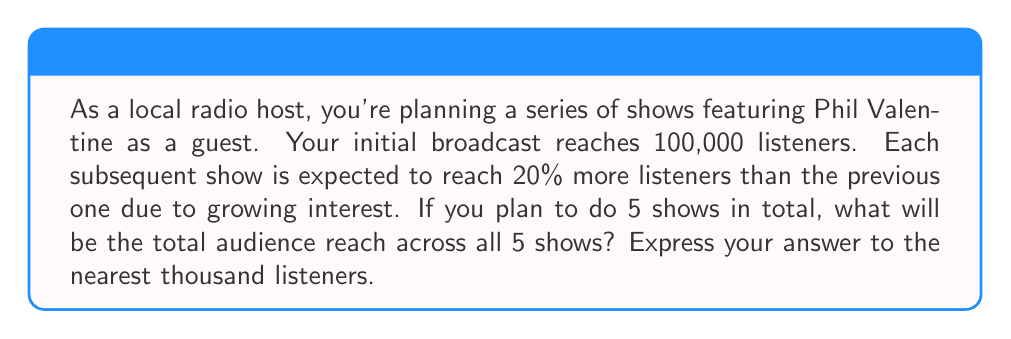Help me with this question. To solve this problem, we need to use the formula for the sum of a geometric series:

$$S_n = \frac{a(1-r^n)}{1-r}$$

Where:
$S_n$ is the sum of the series
$a$ is the first term
$r$ is the common ratio
$n$ is the number of terms

Let's identify these values:
$a = 100,000$ (initial audience)
$r = 1.20$ (20% increase = 1.20 times the previous)
$n = 5$ (number of shows)

Now, let's substitute these values into our formula:

$$S_5 = \frac{100,000(1-1.20^5)}{1-1.20}$$

Simplifying:
$$S_5 = \frac{100,000(1-2.48832)}{-0.20}$$
$$S_5 = \frac{100,000(-1.48832)}{-0.20}$$
$$S_5 = 744,160$$

Rounding to the nearest thousand:
$$S_5 \approx 744,000$$
Answer: 744,000 listeners 